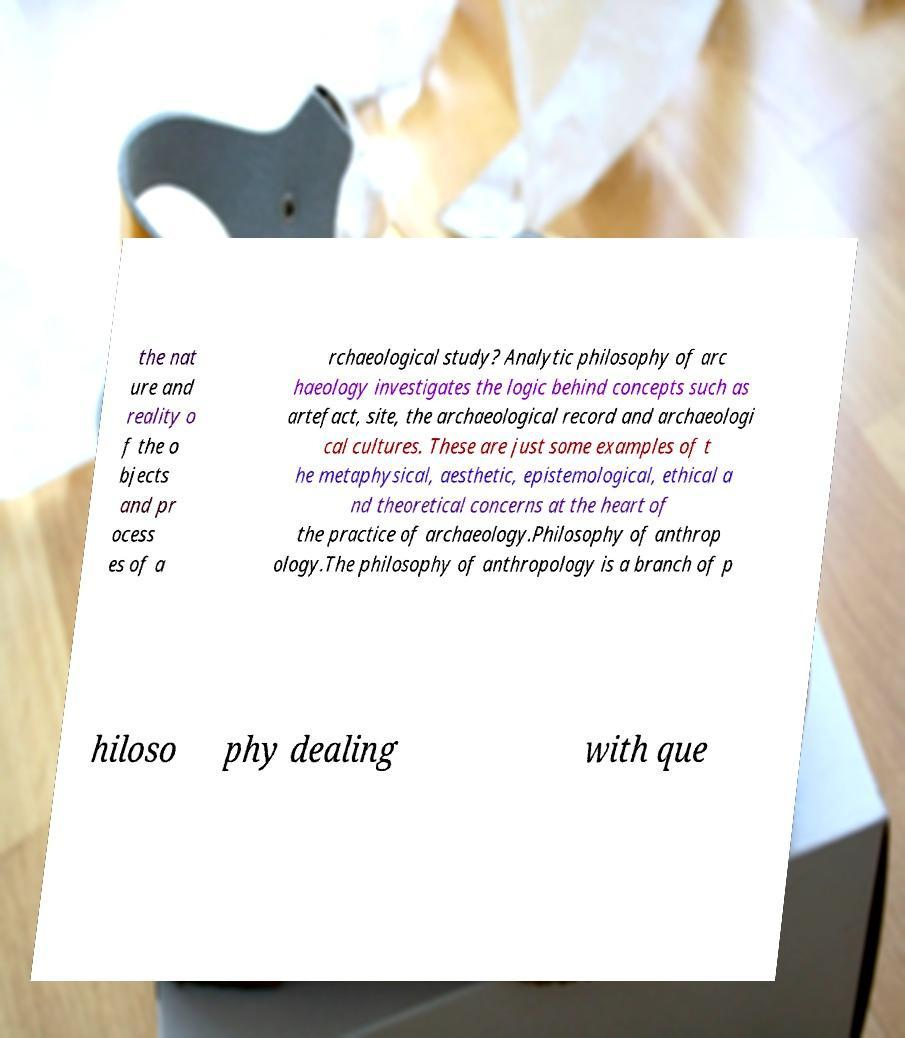Could you extract and type out the text from this image? the nat ure and reality o f the o bjects and pr ocess es of a rchaeological study? Analytic philosophy of arc haeology investigates the logic behind concepts such as artefact, site, the archaeological record and archaeologi cal cultures. These are just some examples of t he metaphysical, aesthetic, epistemological, ethical a nd theoretical concerns at the heart of the practice of archaeology.Philosophy of anthrop ology.The philosophy of anthropology is a branch of p hiloso phy dealing with que 